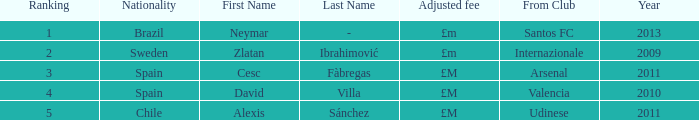What is the most recent year a player was from Valencia? 2010.0. 